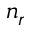<formula> <loc_0><loc_0><loc_500><loc_500>n _ { r }</formula> 